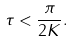<formula> <loc_0><loc_0><loc_500><loc_500>\tau < \frac { \pi } { 2 K } .</formula> 